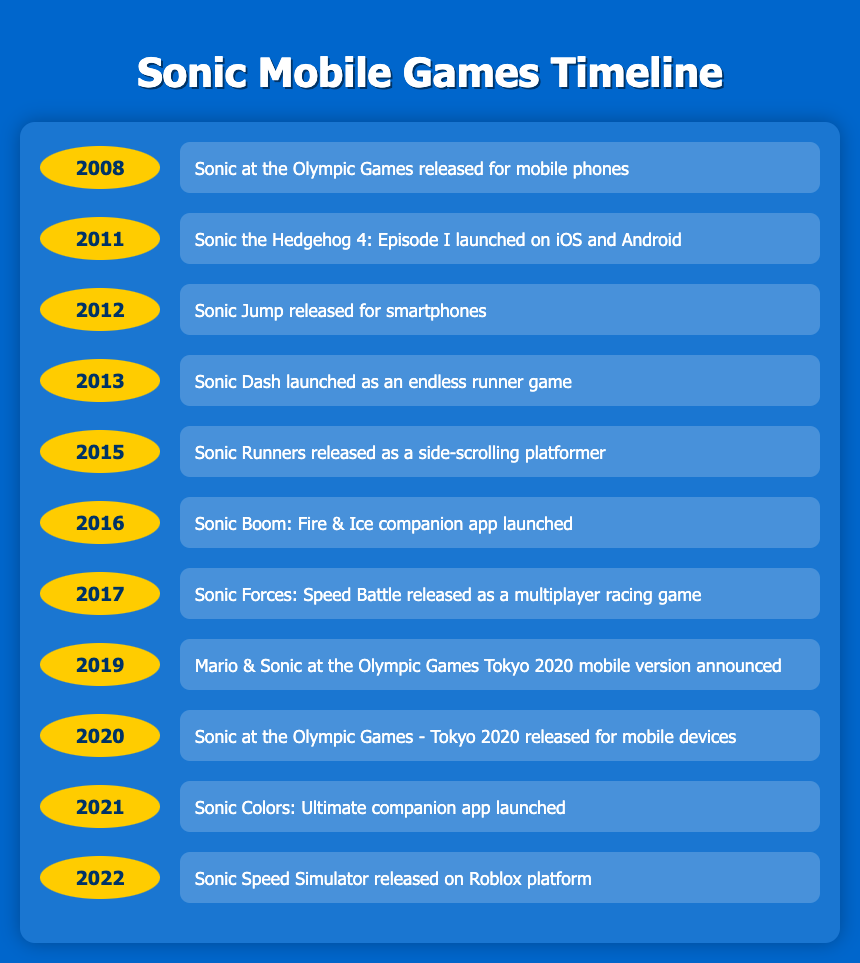What year was Sonic Jump released for smartphones? Referring to the timeline, Sonic Jump was released in 2012.
Answer: 2012 What mobile game was launched in 2016? According to the table, Sonic Boom: Fire & Ice companion app was launched in 2016.
Answer: Sonic Boom: Fire & Ice companion app How many years are there between the release of Sonic Dash and Sonic Runners? Sonic Dash was released in 2013 and Sonic Runners was released in 2015. The difference is 2015 - 2013 = 2 years.
Answer: 2 years Was Sonic at the Olympic Games - Tokyo 2020 released in 2020? The timeline states that Sonic at the Olympic Games - Tokyo 2020 was indeed released in 2020.
Answer: Yes What is the total number of mobile games released from 2008 to 2017? Counting the games from the years 2008 to 2017 listed in the timeline gives us Sonic at the Olympic Games, Sonic the Hedgehog 4: Episode I, Sonic Jump, Sonic Dash, Sonic Runners, Sonic Boom: Fire & Ice, and Sonic Forces: Speed Battle. That's a total of 7 games.
Answer: 7 games In what year did the Mario & Sonic at the Olympic Games Tokyo 2020 mobile version get announced? The timeline indicates that Mario & Sonic at the Olympic Games Tokyo 2020 mobile version was announced in 2019.
Answer: 2019 Which game was launched first: Sonic at the Olympic Games or Sonic the Hedgehog 4: Episode I? Sonic at the Olympic Games was released in 2008, while Sonic the Hedgehog 4: Episode I was launched in 2011. Therefore, Sonic at the Olympic Games was released first.
Answer: Sonic at the Olympic Games Was there a mobile game related to Sonic Colors released in 2021? The timeline confirms that there was a companion app for Sonic Colors: Ultimate launched in 2021.
Answer: Yes What game represents the last entry in the timeline and in what year was it released? The last game mentioned in the timeline is Sonic Speed Simulator, which was released in 2022.
Answer: Sonic Speed Simulator, 2022 